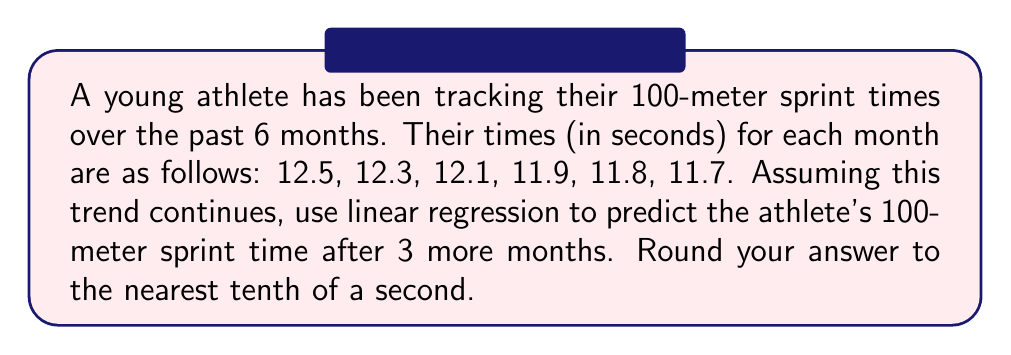Help me with this question. To predict the athlete's future performance using time series analysis, we'll use linear regression.

Step 1: Set up the data points.
Let x represent the month number (1 to 6) and y represent the sprint time.
(1, 12.5), (2, 12.3), (3, 12.1), (4, 11.9), (5, 11.8), (6, 11.7)

Step 2: Calculate the means of x and y.
$\bar{x} = \frac{1+2+3+4+5+6}{6} = 3.5$
$\bar{y} = \frac{12.5+12.3+12.1+11.9+11.8+11.7}{6} = 12.05$

Step 3: Calculate the slope (m) of the regression line.
$$m = \frac{\sum(x_i - \bar{x})(y_i - \bar{y})}{\sum(x_i - \bar{x})^2}$$

Numerator: $(-2.5)(-0.45) + (-1.5)(-0.25) + (-0.5)(-0.05) + (0.5)(0.15) + (1.5)(0.25) + (2.5)(0.35) = 2.35$
Denominator: $(-2.5)^2 + (-1.5)^2 + (-0.5)^2 + (0.5)^2 + (1.5)^2 + (2.5)^2 = 17.5$

$m = \frac{2.35}{17.5} = -0.134$

Step 4: Calculate the y-intercept (b) of the regression line.
$b = \bar{y} - m\bar{x} = 12.05 - (-0.134)(3.5) = 12.519$

Step 5: Use the regression equation $y = mx + b$ to predict the sprint time after 3 more months (x = 9).
$y = -0.134(9) + 12.519 = 11.313$

Step 6: Round to the nearest tenth.
11.3 seconds
Answer: 11.3 seconds 